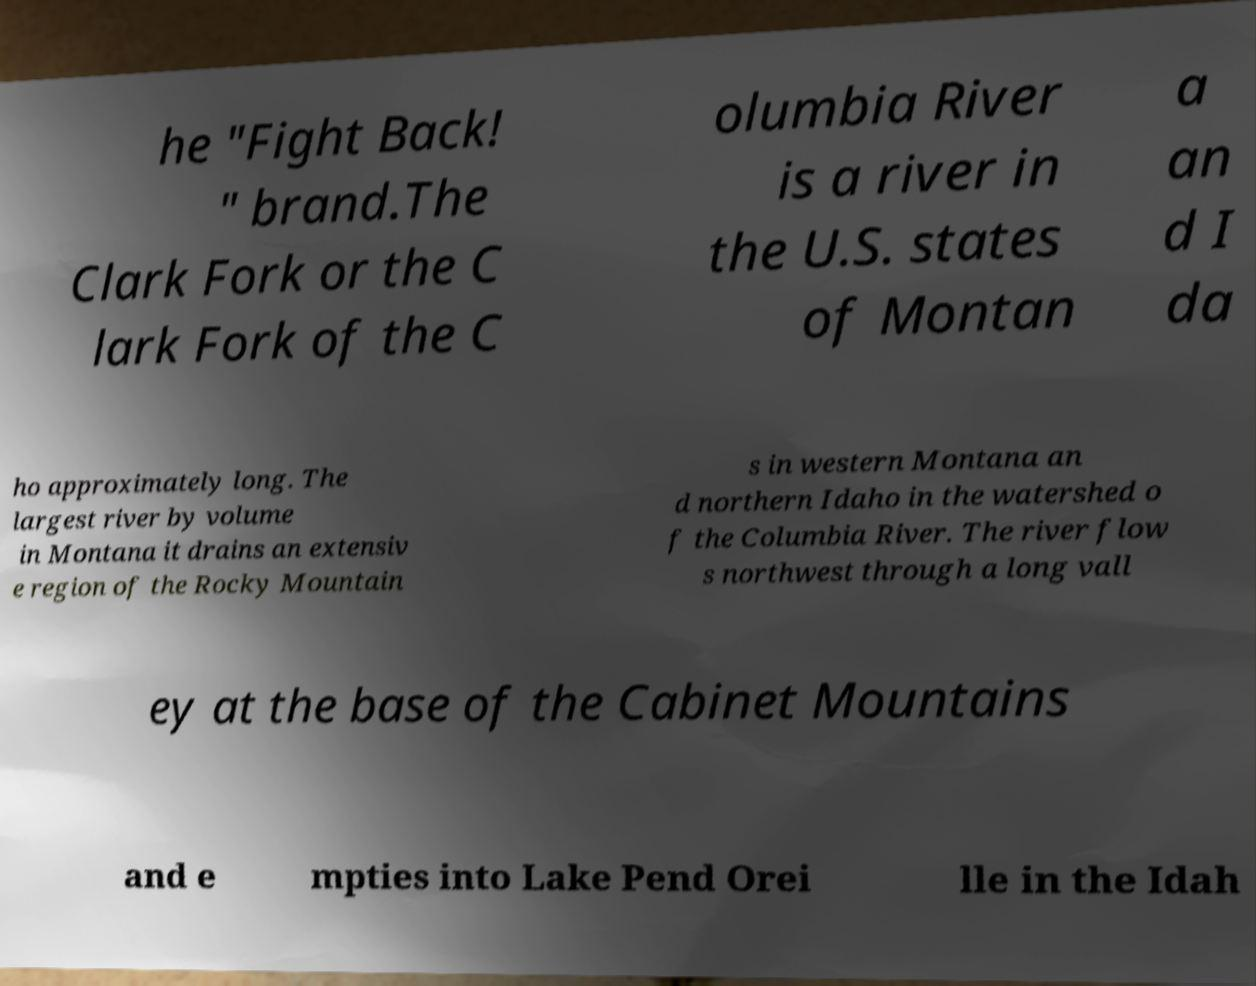Please identify and transcribe the text found in this image. he "Fight Back! " brand.The Clark Fork or the C lark Fork of the C olumbia River is a river in the U.S. states of Montan a an d I da ho approximately long. The largest river by volume in Montana it drains an extensiv e region of the Rocky Mountain s in western Montana an d northern Idaho in the watershed o f the Columbia River. The river flow s northwest through a long vall ey at the base of the Cabinet Mountains and e mpties into Lake Pend Orei lle in the Idah 